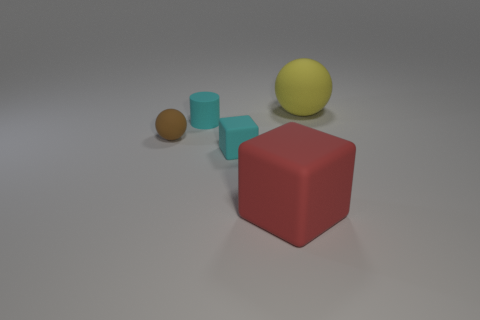What is the material of the red cube that is the same size as the yellow rubber ball?
Offer a terse response. Rubber. What is the shape of the thing that is both behind the tiny cyan matte cube and to the right of the cylinder?
Your response must be concise. Sphere. There is a cube that is the same size as the cylinder; what color is it?
Offer a terse response. Cyan. There is a matte sphere left of the big yellow ball; is its size the same as the rubber ball that is behind the tiny brown matte ball?
Offer a very short reply. No. What size is the red thing to the right of the small cyan thing behind the rubber ball in front of the yellow thing?
Keep it short and to the point. Large. What shape is the tiny thing that is behind the rubber ball that is in front of the yellow sphere?
Offer a terse response. Cylinder. There is a rubber object on the right side of the big red object; is its color the same as the small ball?
Offer a terse response. No. There is a thing that is both behind the small ball and on the left side of the big yellow rubber sphere; what is its color?
Keep it short and to the point. Cyan. Is there a cyan cube made of the same material as the red thing?
Offer a terse response. Yes. What size is the red rubber cube?
Offer a terse response. Large. 